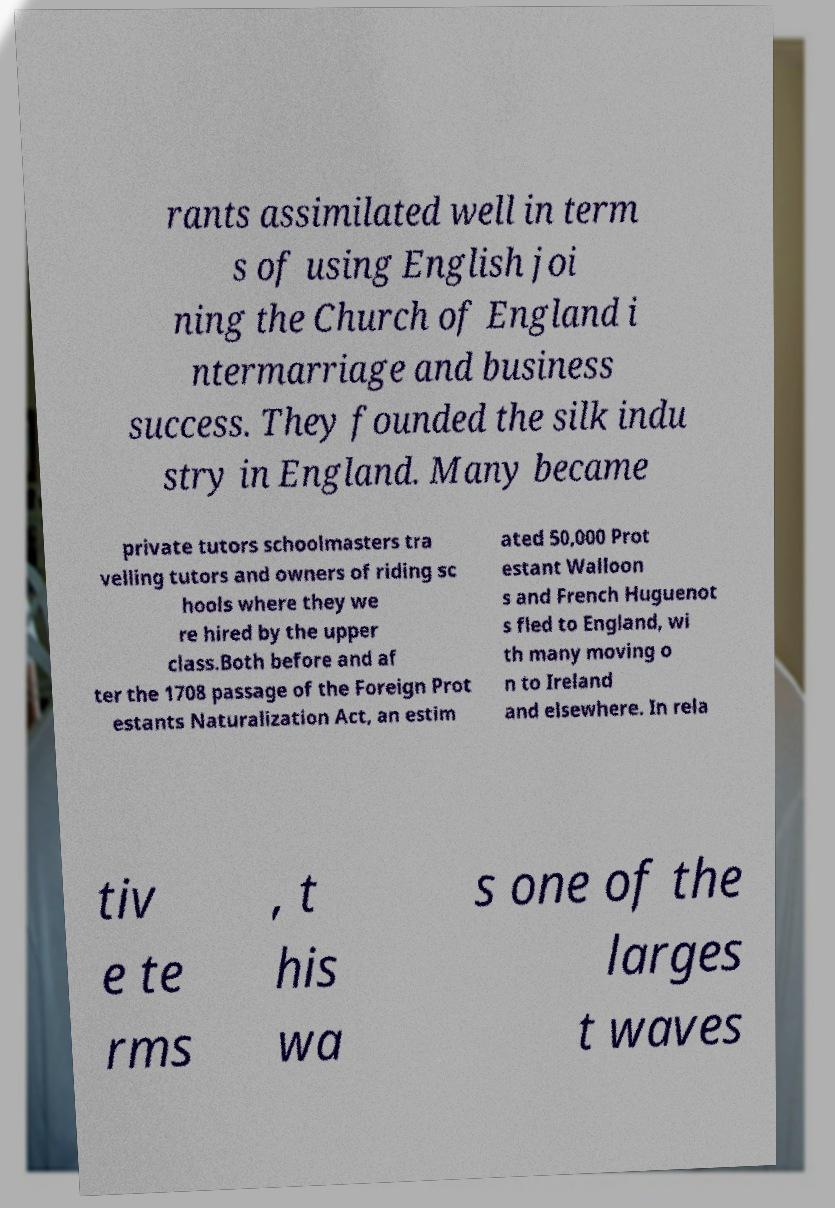Could you extract and type out the text from this image? rants assimilated well in term s of using English joi ning the Church of England i ntermarriage and business success. They founded the silk indu stry in England. Many became private tutors schoolmasters tra velling tutors and owners of riding sc hools where they we re hired by the upper class.Both before and af ter the 1708 passage of the Foreign Prot estants Naturalization Act, an estim ated 50,000 Prot estant Walloon s and French Huguenot s fled to England, wi th many moving o n to Ireland and elsewhere. In rela tiv e te rms , t his wa s one of the larges t waves 